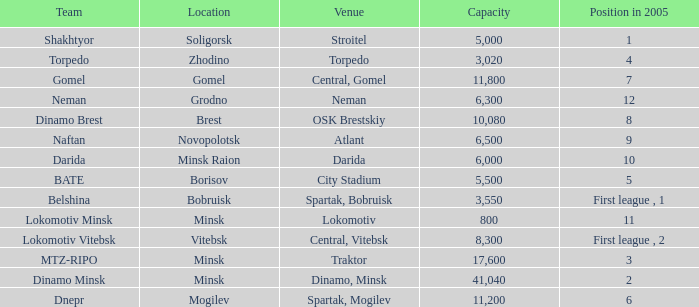What is the maximum capacity of the torpedo team? 3020.0. 